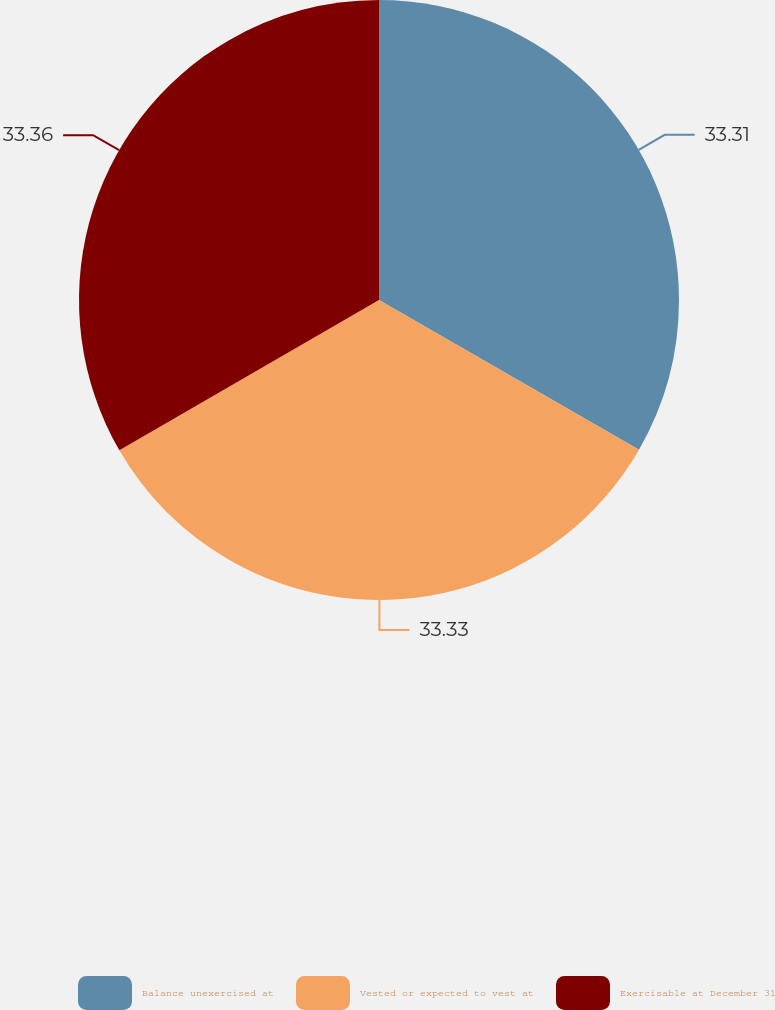Convert chart to OTSL. <chart><loc_0><loc_0><loc_500><loc_500><pie_chart><fcel>Balance unexercised at<fcel>Vested or expected to vest at<fcel>Exercisable at December 31<nl><fcel>33.31%<fcel>33.33%<fcel>33.35%<nl></chart> 